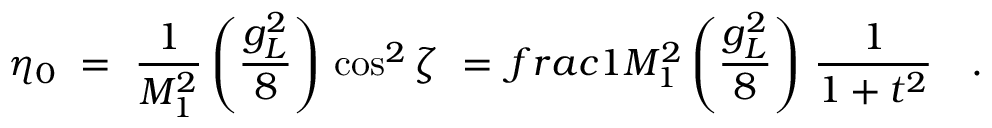Convert formula to latex. <formula><loc_0><loc_0><loc_500><loc_500>\eta _ { 0 } \ = \ \frac { 1 } { M _ { 1 } ^ { 2 } } \left ( \frac { g _ { L } ^ { 2 } } { 8 } \right ) \, \cos ^ { 2 } \zeta \ = \, f r a c { 1 } { M _ { 1 } ^ { 2 } } \left ( \frac { g _ { L } ^ { 2 } } { 8 } \right ) \, \frac { 1 } { 1 + t ^ { 2 } } \quad .</formula> 